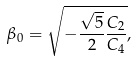Convert formula to latex. <formula><loc_0><loc_0><loc_500><loc_500>\beta _ { 0 } = \sqrt { - \frac { \sqrt { 5 } } { 2 } \frac { C _ { 2 } } { C _ { 4 } } } ,</formula> 